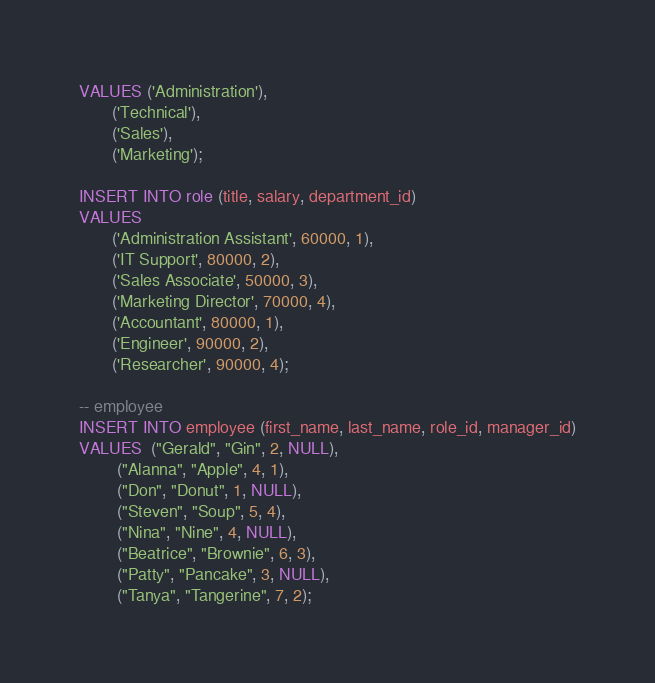Convert code to text. <code><loc_0><loc_0><loc_500><loc_500><_SQL_>VALUES ('Administration'),
       ('Technical'),
       ('Sales'),
       ('Marketing');

INSERT INTO role (title, salary, department_id)
VALUES 
       ('Administration Assistant', 60000, 1),
       ('IT Support', 80000, 2),
       ('Sales Associate', 50000, 3),
       ('Marketing Director', 70000, 4),
       ('Accountant', 80000, 1),
       ('Engineer', 90000, 2),
       ('Researcher', 90000, 4);

-- employee
INSERT INTO employee (first_name, last_name, role_id, manager_id)
VALUES  ("Gerald", "Gin", 2, NULL),
        ("Alanna", "Apple", 4, 1),
        ("Don", "Donut", 1, NULL),
        ("Steven", "Soup", 5, 4),
        ("Nina", "Nine", 4, NULL),
        ("Beatrice", "Brownie", 6, 3),
        ("Patty", "Pancake", 3, NULL),
        ("Tanya", "Tangerine", 7, 2);</code> 